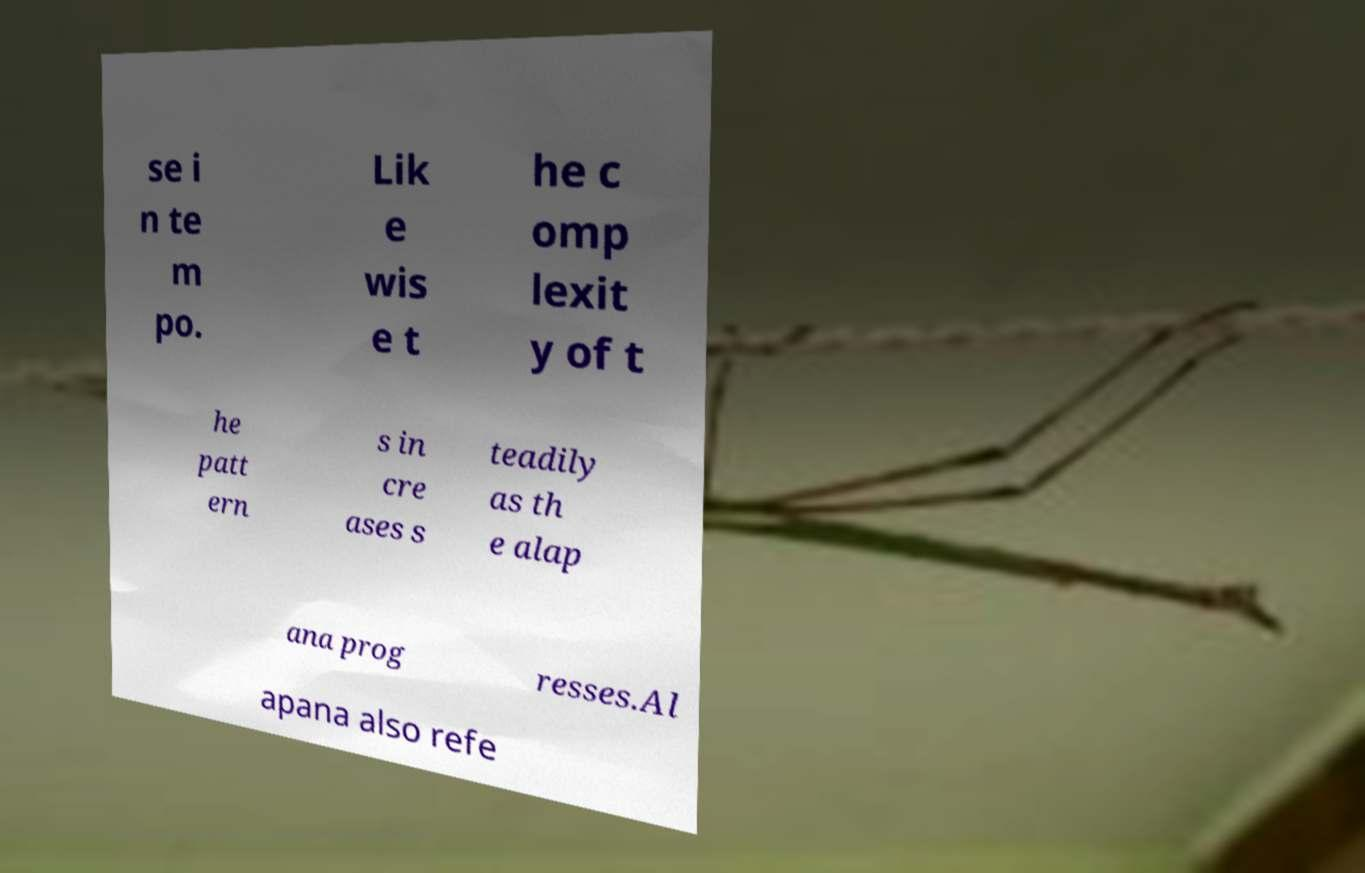For documentation purposes, I need the text within this image transcribed. Could you provide that? se i n te m po. Lik e wis e t he c omp lexit y of t he patt ern s in cre ases s teadily as th e alap ana prog resses.Al apana also refe 